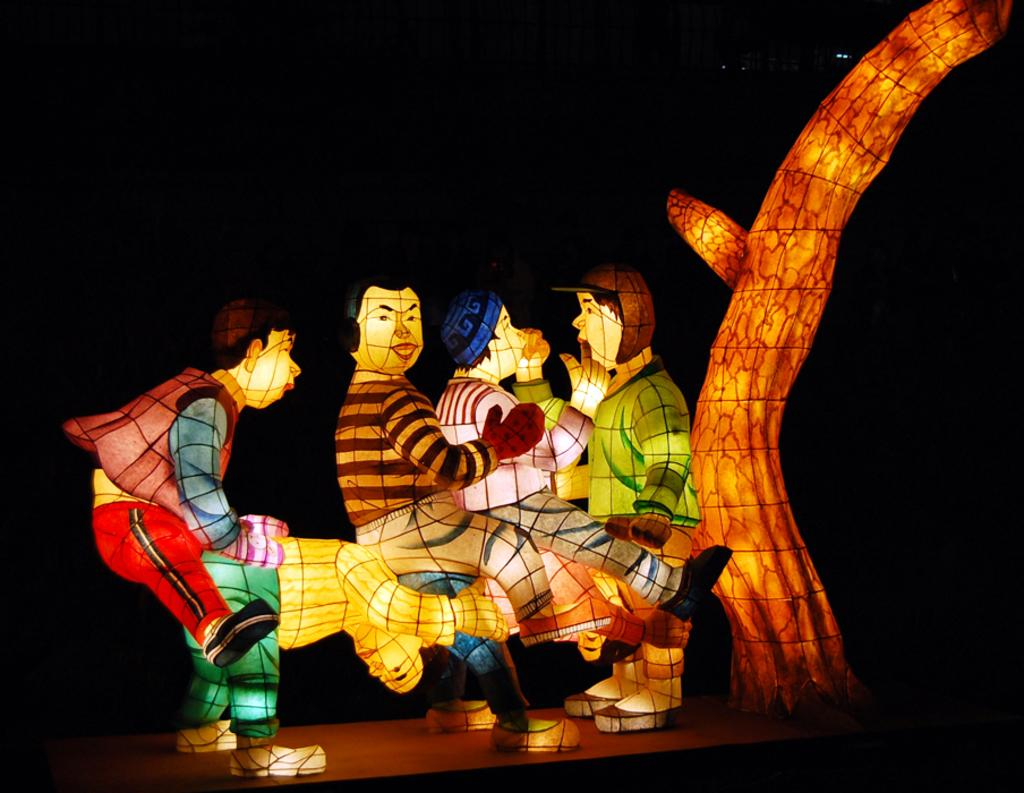Who or what can be seen in the image? There are persons depicted in the image. What is happening in the image? There is a bark with lightning in the image. What type of path is present in the image? There is a wooden path in the image. What is the color of the background in the image? The background of the image is in black color. What direction are the persons walking in the image? There is no indication of the persons walking in the image, as they are not depicted in motion. Can you see a suit hanging in the cellar in the image? There is no cellar or suit present in the image. 